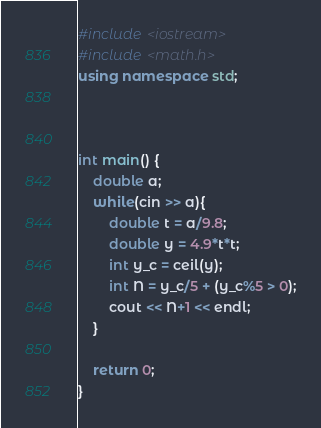Convert code to text. <code><loc_0><loc_0><loc_500><loc_500><_C++_>#include <iostream>
#include <math.h>
using namespace std;



int main() {
	double a;
	while(cin >> a){
		double t = a/9.8;
		double y = 4.9*t*t;
		int y_c = ceil(y);
		int N = y_c/5 + (y_c%5 > 0);
		cout << N+1 << endl;
	}
	 
	return 0;
}</code> 